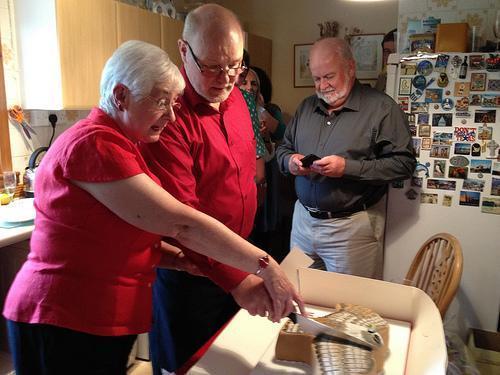How many people are wearing red?
Give a very brief answer. 2. 